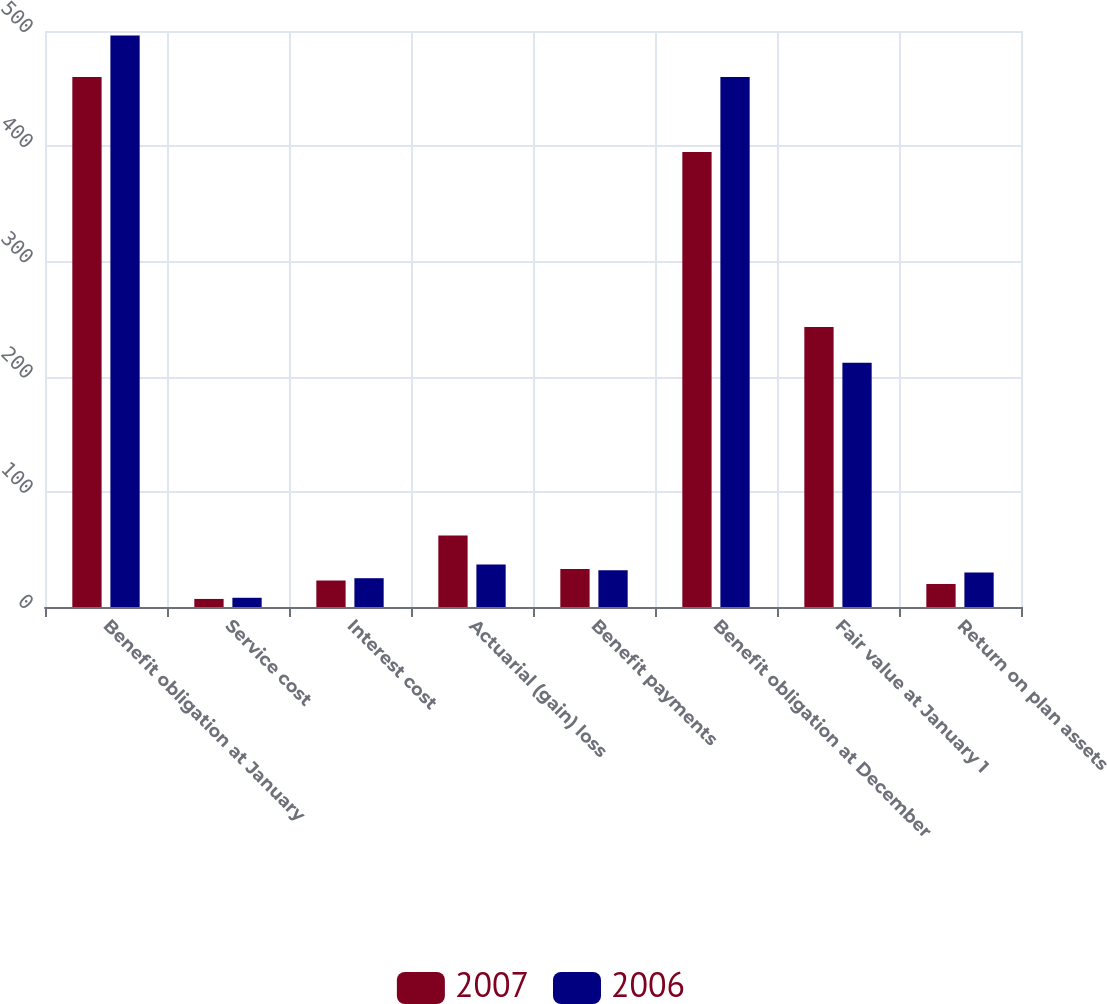Convert chart to OTSL. <chart><loc_0><loc_0><loc_500><loc_500><stacked_bar_chart><ecel><fcel>Benefit obligation at January<fcel>Service cost<fcel>Interest cost<fcel>Actuarial (gain) loss<fcel>Benefit payments<fcel>Benefit obligation at December<fcel>Fair value at January 1<fcel>Return on plan assets<nl><fcel>2007<fcel>460<fcel>7<fcel>23<fcel>62<fcel>33<fcel>395<fcel>243<fcel>20<nl><fcel>2006<fcel>496<fcel>8<fcel>25<fcel>37<fcel>32<fcel>460<fcel>212<fcel>30<nl></chart> 